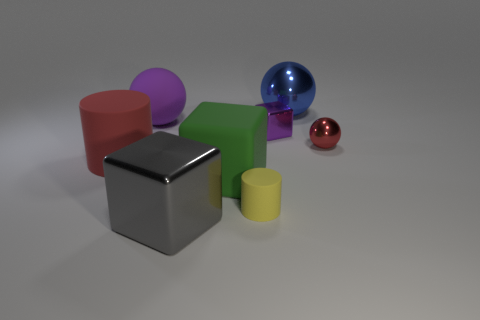What size is the object that is both behind the tiny purple block and on the left side of the green object?
Your answer should be very brief. Large. What number of other objects are the same material as the green thing?
Offer a terse response. 3. How big is the metallic cube that is behind the red shiny thing?
Give a very brief answer. Small. Does the big rubber cylinder have the same color as the small metallic sphere?
Give a very brief answer. Yes. How many large things are either rubber cubes or shiny objects?
Keep it short and to the point. 3. Is there anything else that has the same color as the small shiny block?
Provide a short and direct response. Yes. There is a purple matte sphere; are there any green blocks in front of it?
Offer a terse response. Yes. There is a metal cube in front of the small thing behind the small sphere; what size is it?
Make the answer very short. Large. Are there the same number of tiny shiny cubes on the left side of the matte cube and big metal spheres right of the big gray metallic object?
Keep it short and to the point. No. There is a tiny metal object right of the small purple object; is there a thing left of it?
Provide a succinct answer. Yes. 